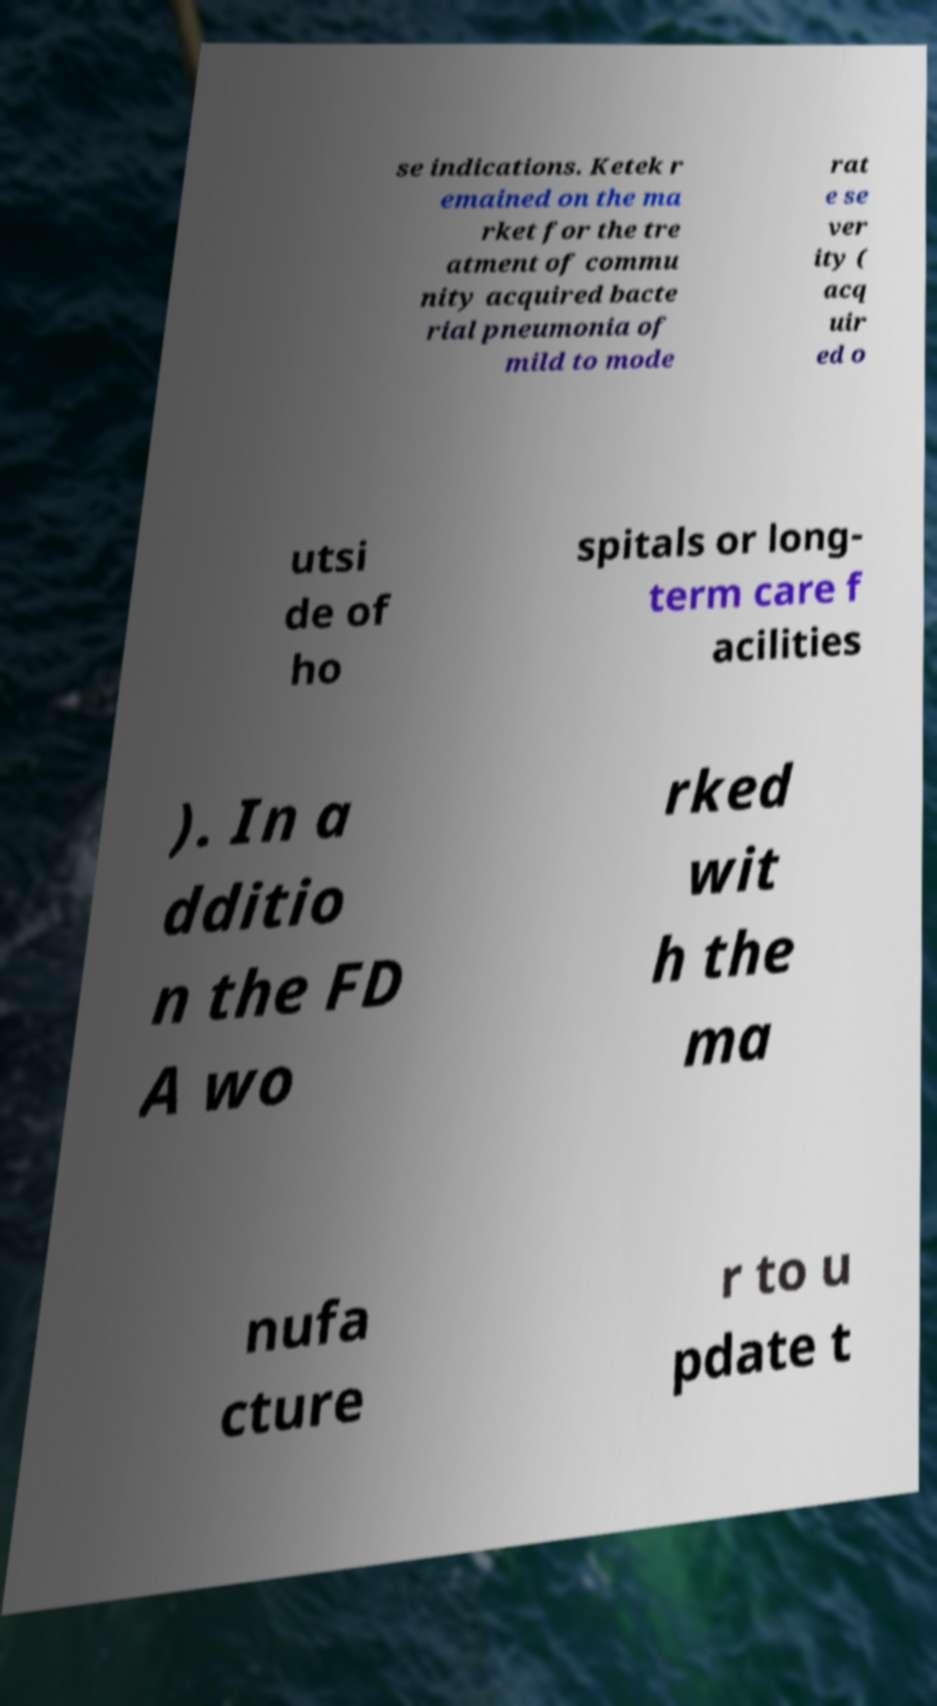Can you accurately transcribe the text from the provided image for me? se indications. Ketek r emained on the ma rket for the tre atment of commu nity acquired bacte rial pneumonia of mild to mode rat e se ver ity ( acq uir ed o utsi de of ho spitals or long- term care f acilities ). In a dditio n the FD A wo rked wit h the ma nufa cture r to u pdate t 